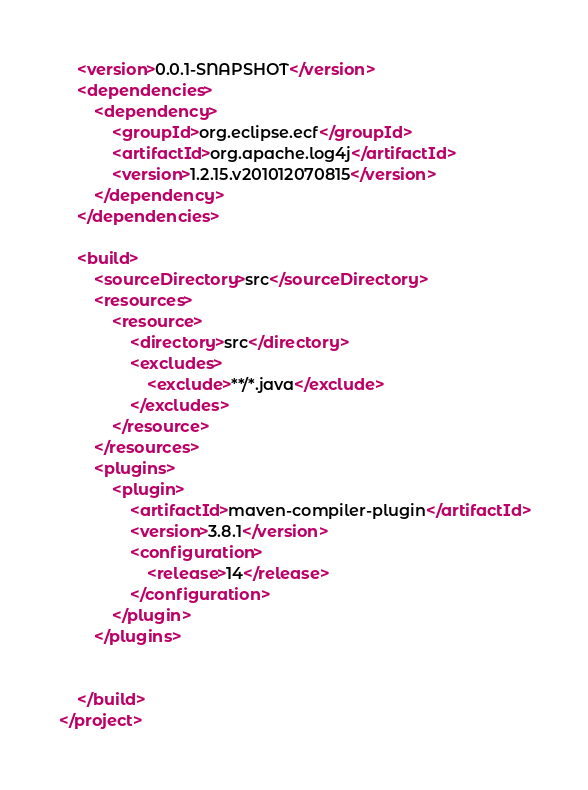Convert code to text. <code><loc_0><loc_0><loc_500><loc_500><_XML_>
	<version>0.0.1-SNAPSHOT</version>
	<dependencies>
		<dependency>
			<groupId>org.eclipse.ecf</groupId>
			<artifactId>org.apache.log4j</artifactId>
			<version>1.2.15.v201012070815</version>
		</dependency>
	</dependencies>

	<build>
		<sourceDirectory>src</sourceDirectory>
		<resources>
			<resource>
				<directory>src</directory>
				<excludes>
					<exclude>**/*.java</exclude>
				</excludes>
			</resource>
		</resources>
		<plugins>
			<plugin>
				<artifactId>maven-compiler-plugin</artifactId>
				<version>3.8.1</version>
				<configuration>
					<release>14</release>
				</configuration>
			</plugin>
		</plugins>


	</build>
</project></code> 